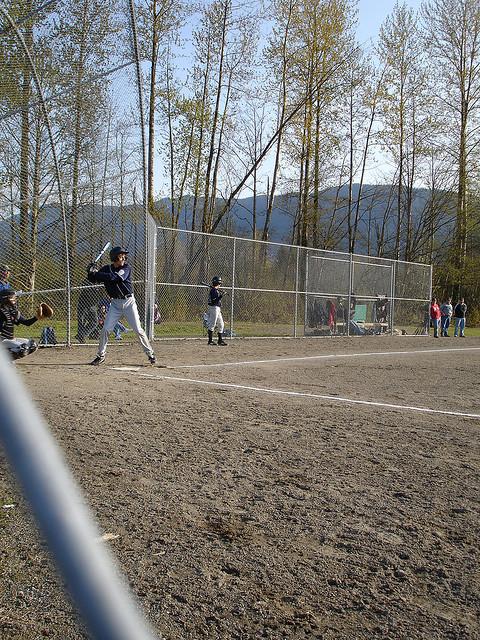What number of men are holding bats?
Be succinct. 1. Is this person at 3rd base?
Answer briefly. No. What sport are they playing?
Write a very short answer. Baseball. 